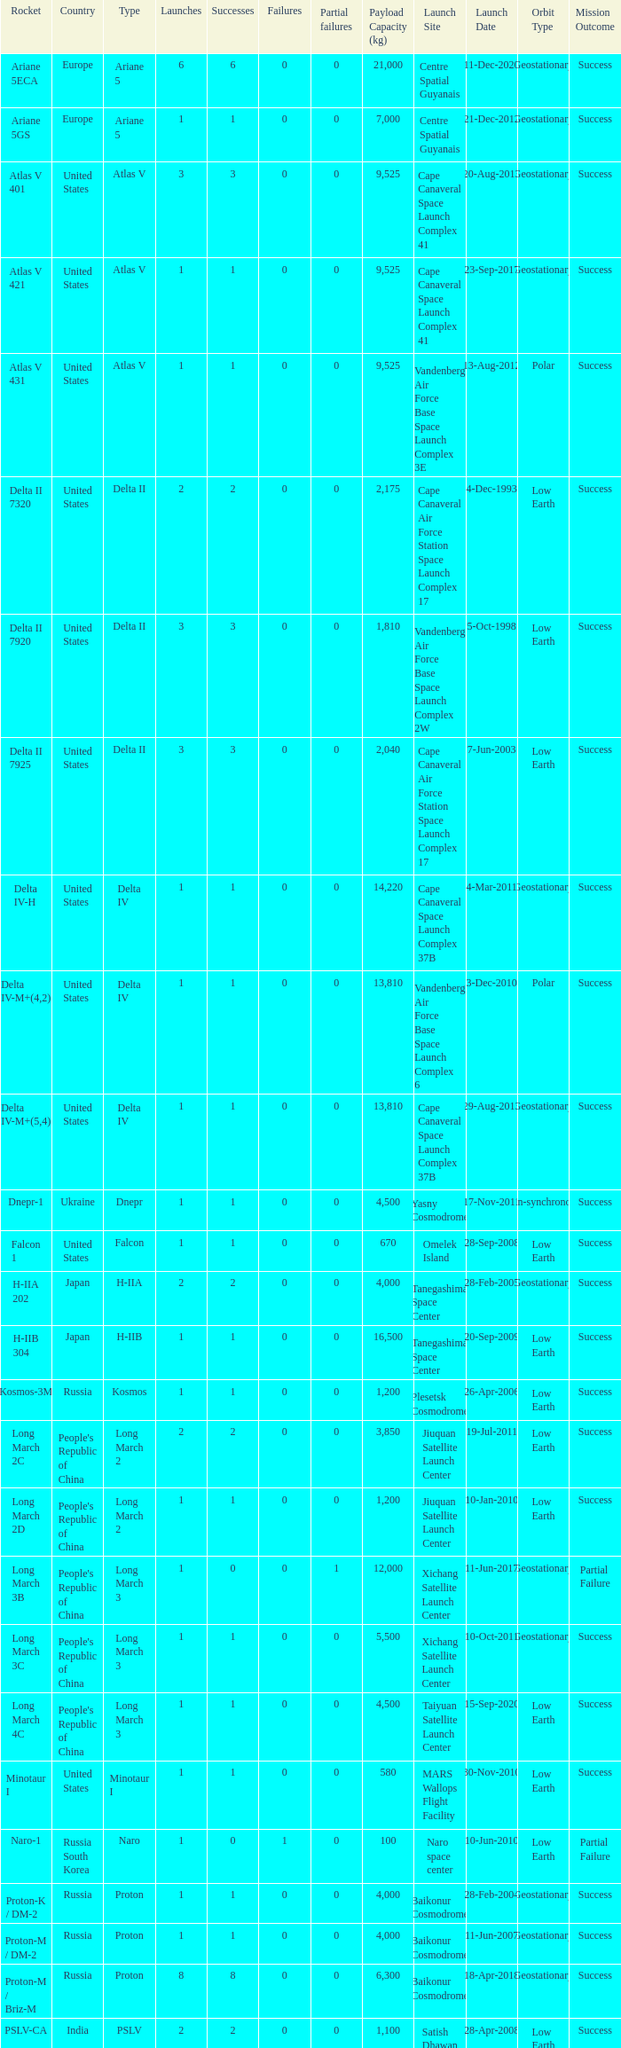What's the total failures among rockets that had more than 3 successes, type ariane 5 and more than 0 partial failures? 0.0. Give me the full table as a dictionary. {'header': ['Rocket', 'Country', 'Type', 'Launches', 'Successes', 'Failures', 'Partial failures', 'Payload Capacity (kg)', 'Launch Site', 'Launch Date', 'Orbit Type', 'Mission Outcome'], 'rows': [['Ariane 5ECA', 'Europe', 'Ariane 5', '6', '6', '0', '0', '21,000', 'Centre Spatial Guyanais', '11-Dec-2020', 'Geostationary', 'Success'], ['Ariane 5GS', 'Europe', 'Ariane 5', '1', '1', '0', '0', '7,000', 'Centre Spatial Guyanais', '21-Dec-2012', 'Geostationary', 'Success'], ['Atlas V 401', 'United States', 'Atlas V', '3', '3', '0', '0', '9,525', 'Cape Canaveral Space Launch Complex 41', '20-Aug-2013', 'Geostationary', 'Success'], ['Atlas V 421', 'United States', 'Atlas V', '1', '1', '0', '0', '9,525', 'Cape Canaveral Space Launch Complex 41', '23-Sep-2017', 'Geostationary', 'Success'], ['Atlas V 431', 'United States', 'Atlas V', '1', '1', '0', '0', '9,525', 'Vandenberg Air Force Base Space Launch Complex 3E', '13-Aug-2012', 'Polar', 'Success'], ['Delta II 7320', 'United States', 'Delta II', '2', '2', '0', '0', '2,175', 'Cape Canaveral Air Force Station Space Launch Complex 17', '4-Dec-1993', 'Low Earth', 'Success'], ['Delta II 7920', 'United States', 'Delta II', '3', '3', '0', '0', '1,810', 'Vandenberg Air Force Base Space Launch Complex 2W', '5-Oct-1998', 'Low Earth', 'Success'], ['Delta II 7925', 'United States', 'Delta II', '3', '3', '0', '0', '2,040', 'Cape Canaveral Air Force Station Space Launch Complex 17', '7-Jun-2003', 'Low Earth', 'Success'], ['Delta IV-H', 'United States', 'Delta IV', '1', '1', '0', '0', '14,220', 'Cape Canaveral Space Launch Complex 37B', '4-Mar-2011', 'Geostationary', 'Success'], ['Delta IV-M+(4,2)', 'United States', 'Delta IV', '1', '1', '0', '0', '13,810', 'Vandenberg Air Force Base Space Launch Complex 6', '3-Dec-2010', 'Polar', 'Success'], ['Delta IV-M+(5,4)', 'United States', 'Delta IV', '1', '1', '0', '0', '13,810', 'Cape Canaveral Space Launch Complex 37B', '29-Aug-2013', 'Geostationary', 'Success'], ['Dnepr-1', 'Ukraine', 'Dnepr', '1', '1', '0', '0', '4,500', 'Yasny Cosmodrome', '17-Nov-2011', 'Sun-synchronous', 'Success'], ['Falcon 1', 'United States', 'Falcon', '1', '1', '0', '0', '670', 'Omelek Island', '28-Sep-2008', 'Low Earth', 'Success'], ['H-IIA 202', 'Japan', 'H-IIA', '2', '2', '0', '0', '4,000', 'Tanegashima Space Center', '28-Feb-2005', 'Geostationary', 'Success'], ['H-IIB 304', 'Japan', 'H-IIB', '1', '1', '0', '0', '16,500', 'Tanegashima Space Center', '20-Sep-2009', 'Low Earth', 'Success'], ['Kosmos-3M', 'Russia', 'Kosmos', '1', '1', '0', '0', '1,200', 'Plesetsk Cosmodrome', '26-Apr-2006', 'Low Earth', 'Success'], ['Long March 2C', "People's Republic of China", 'Long March 2', '2', '2', '0', '0', '3,850', 'Jiuquan Satellite Launch Center', '19-Jul-2011', 'Low Earth', 'Success'], ['Long March 2D', "People's Republic of China", 'Long March 2', '1', '1', '0', '0', '1,200', 'Jiuquan Satellite Launch Center', '10-Jan-2010', 'Low Earth', 'Success'], ['Long March 3B', "People's Republic of China", 'Long March 3', '1', '0', '0', '1', '12,000', 'Xichang Satellite Launch Center', '11-Jun-2017', 'Geostationary', 'Partial Failure'], ['Long March 3C', "People's Republic of China", 'Long March 3', '1', '1', '0', '0', '5,500', 'Xichang Satellite Launch Center', '10-Oct-2011', 'Geostationary', 'Success'], ['Long March 4C', "People's Republic of China", 'Long March 3', '1', '1', '0', '0', '4,500', 'Taiyuan Satellite Launch Center', '15-Sep-2020', 'Low Earth', 'Success'], ['Minotaur I', 'United States', 'Minotaur I', '1', '1', '0', '0', '580', 'MARS Wallops Flight Facility', '30-Nov-2010', 'Low Earth', 'Success'], ['Naro-1', 'Russia South Korea', 'Naro', '1', '0', '1', '0', '100', 'Naro space center', '10-Jun-2010', 'Low Earth', 'Partial Failure'], ['Proton-K / DM-2', 'Russia', 'Proton', '1', '1', '0', '0', '4,000', 'Baikonur Cosmodrome', '28-Feb-2004', 'Geostationary', 'Success'], ['Proton-M / DM-2', 'Russia', 'Proton', '1', '1', '0', '0', '4,000', 'Baikonur Cosmodrome', '11-Jun-2007', 'Geostationary', 'Success'], ['Proton-M / Briz-M', 'Russia', 'Proton', '8', '8', '0', '0', '6,300', 'Baikonur Cosmodrome', '18-Apr-2018', 'Geostationary', 'Success'], ['PSLV-CA', 'India', 'PSLV', '2', '2', '0', '0', '1,100', 'Satish Dhawan Space Centre', '28-Apr-2008', 'Low Earth', 'Success'], ['Rokot / Briz-KM', 'Russia', 'UR-100', '3', '3', '0', '0', '1,950', 'Plesetsk Cosmodrome', '6-Dec-2014', 'Low Earth', 'Success'], ['Safir', 'Iran', 'Safir', '1', '1', '0', '0', '50', 'Semnan spaceport', '2-Feb-2009', 'Low Earth', 'Success'], ['Soyuz-2.1a / Fregat', 'Russia', 'Soyuz', '1', '0', '1', '0', '1,200', 'Vostochny Cosmodrome', '28-Nov-2017', 'Sun-synchronous', 'Partial Failure'], ['Soyuz-2.1b / Fregat', 'Russia', 'Soyuz', '1', '1', '0', '0', '7,800', 'Baikonur Cosmodrome', '28-Jul-2019', 'Geostationary', 'Success'], ['Soyuz-FG', 'Russia', 'Soyuz', '4', '4', '0', '0', '7,220', 'Baikonur Cosmodrome', '14-Mar-2019', 'Low Earth', 'Success'], ['Soyuz-U', 'Russia', 'Soyuz', '7', '7', '0', '0', '6,450', 'Baikonur Cosmodrome', '27-Jul-2017', 'Low Earth', 'Success'], ['Space Shuttle', 'United States', 'Space Shuttle', '5', '5', '0', '0', '24,400', 'Kennedy Space Center Launch Complex 39A or 39B', '8-Jul-2011', 'Low Earth', 'Success'], ['Taurus-XL 3110', 'United States', 'Taurus', '1', '0', '1', '0', '1,470', 'Vandenberg Air Force Base Space Launch Complex 576E', '4-Feb-2009', 'Low Earth', 'Partial Failure'], ['Tsyklon-3', 'Ukraine', 'Tsyklon', '1', '1', '0', '0', '1,800', 'Plesetsk Cosmodrome', '30-Jan-2007', 'Low Earth', 'Success'], ['Unha', 'North Korea', 'Unha', '1', '0', '1', '0', 'Unknown', 'Tonghae Satellite Launching Ground', '13-Apr-2012', 'Low Earth', 'Partial Failure'], ['Zenit-3SL', 'Ukraine', 'Zenit', '1', '1', '0', '0', '4,150', 'Odyssey', '28-Sep-2011', 'Geostationary', 'Success'], ['Zenit-3SLB', 'Ukraine', 'Zenit', '3', '3', '0', '0', '6,050', 'Baikonur Cosmodrome', '1-Feb-2013', 'Geostationary', 'Success']]} 